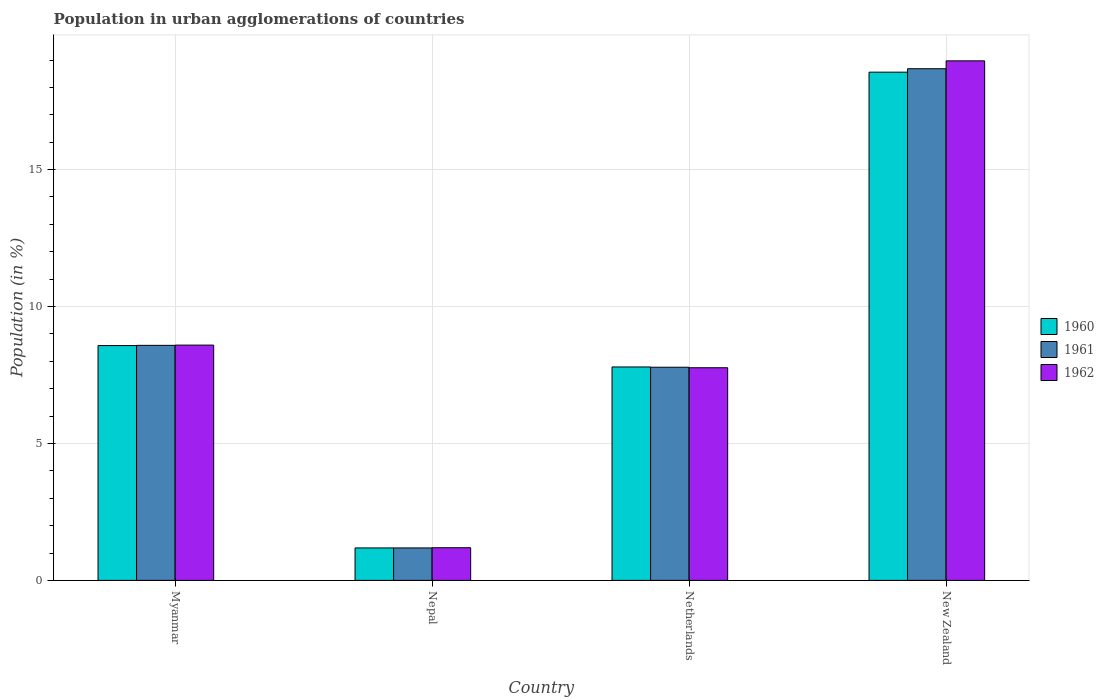How many groups of bars are there?
Provide a succinct answer. 4. Are the number of bars per tick equal to the number of legend labels?
Your answer should be very brief. Yes. Are the number of bars on each tick of the X-axis equal?
Ensure brevity in your answer.  Yes. How many bars are there on the 1st tick from the left?
Offer a very short reply. 3. What is the label of the 4th group of bars from the left?
Make the answer very short. New Zealand. What is the percentage of population in urban agglomerations in 1961 in Netherlands?
Give a very brief answer. 7.78. Across all countries, what is the maximum percentage of population in urban agglomerations in 1961?
Offer a terse response. 18.68. Across all countries, what is the minimum percentage of population in urban agglomerations in 1962?
Your answer should be very brief. 1.19. In which country was the percentage of population in urban agglomerations in 1960 maximum?
Keep it short and to the point. New Zealand. In which country was the percentage of population in urban agglomerations in 1960 minimum?
Offer a very short reply. Nepal. What is the total percentage of population in urban agglomerations in 1961 in the graph?
Ensure brevity in your answer.  36.23. What is the difference between the percentage of population in urban agglomerations in 1961 in Nepal and that in Netherlands?
Keep it short and to the point. -6.6. What is the difference between the percentage of population in urban agglomerations in 1960 in Nepal and the percentage of population in urban agglomerations in 1962 in Myanmar?
Make the answer very short. -7.41. What is the average percentage of population in urban agglomerations in 1962 per country?
Ensure brevity in your answer.  9.13. What is the difference between the percentage of population in urban agglomerations of/in 1962 and percentage of population in urban agglomerations of/in 1961 in Nepal?
Offer a terse response. 0.01. What is the ratio of the percentage of population in urban agglomerations in 1961 in Netherlands to that in New Zealand?
Offer a very short reply. 0.42. Is the difference between the percentage of population in urban agglomerations in 1962 in Myanmar and Netherlands greater than the difference between the percentage of population in urban agglomerations in 1961 in Myanmar and Netherlands?
Keep it short and to the point. Yes. What is the difference between the highest and the second highest percentage of population in urban agglomerations in 1960?
Ensure brevity in your answer.  -9.98. What is the difference between the highest and the lowest percentage of population in urban agglomerations in 1961?
Offer a very short reply. 17.5. Is the sum of the percentage of population in urban agglomerations in 1960 in Netherlands and New Zealand greater than the maximum percentage of population in urban agglomerations in 1962 across all countries?
Provide a succinct answer. Yes. Is it the case that in every country, the sum of the percentage of population in urban agglomerations in 1961 and percentage of population in urban agglomerations in 1962 is greater than the percentage of population in urban agglomerations in 1960?
Provide a short and direct response. Yes. Are all the bars in the graph horizontal?
Your answer should be compact. No. Are the values on the major ticks of Y-axis written in scientific E-notation?
Provide a short and direct response. No. Does the graph contain any zero values?
Provide a short and direct response. No. Where does the legend appear in the graph?
Offer a terse response. Center right. What is the title of the graph?
Provide a short and direct response. Population in urban agglomerations of countries. What is the label or title of the Y-axis?
Your answer should be very brief. Population (in %). What is the Population (in %) of 1960 in Myanmar?
Ensure brevity in your answer.  8.57. What is the Population (in %) of 1961 in Myanmar?
Provide a succinct answer. 8.58. What is the Population (in %) in 1962 in Myanmar?
Your response must be concise. 8.59. What is the Population (in %) of 1960 in Nepal?
Keep it short and to the point. 1.19. What is the Population (in %) of 1961 in Nepal?
Offer a very short reply. 1.19. What is the Population (in %) in 1962 in Nepal?
Your answer should be compact. 1.19. What is the Population (in %) of 1960 in Netherlands?
Your answer should be compact. 7.79. What is the Population (in %) in 1961 in Netherlands?
Ensure brevity in your answer.  7.78. What is the Population (in %) in 1962 in Netherlands?
Offer a terse response. 7.77. What is the Population (in %) in 1960 in New Zealand?
Provide a short and direct response. 18.56. What is the Population (in %) of 1961 in New Zealand?
Provide a short and direct response. 18.68. What is the Population (in %) in 1962 in New Zealand?
Keep it short and to the point. 18.97. Across all countries, what is the maximum Population (in %) of 1960?
Provide a succinct answer. 18.56. Across all countries, what is the maximum Population (in %) of 1961?
Keep it short and to the point. 18.68. Across all countries, what is the maximum Population (in %) of 1962?
Make the answer very short. 18.97. Across all countries, what is the minimum Population (in %) of 1960?
Your answer should be very brief. 1.19. Across all countries, what is the minimum Population (in %) of 1961?
Your answer should be very brief. 1.19. Across all countries, what is the minimum Population (in %) in 1962?
Your answer should be compact. 1.19. What is the total Population (in %) in 1960 in the graph?
Offer a terse response. 36.11. What is the total Population (in %) of 1961 in the graph?
Provide a succinct answer. 36.23. What is the total Population (in %) in 1962 in the graph?
Your answer should be compact. 36.52. What is the difference between the Population (in %) of 1960 in Myanmar and that in Nepal?
Offer a terse response. 7.39. What is the difference between the Population (in %) in 1961 in Myanmar and that in Nepal?
Offer a very short reply. 7.4. What is the difference between the Population (in %) of 1962 in Myanmar and that in Nepal?
Make the answer very short. 7.4. What is the difference between the Population (in %) in 1960 in Myanmar and that in Netherlands?
Your answer should be compact. 0.78. What is the difference between the Population (in %) of 1961 in Myanmar and that in Netherlands?
Offer a very short reply. 0.8. What is the difference between the Population (in %) of 1962 in Myanmar and that in Netherlands?
Offer a very short reply. 0.83. What is the difference between the Population (in %) in 1960 in Myanmar and that in New Zealand?
Provide a short and direct response. -9.98. What is the difference between the Population (in %) in 1961 in Myanmar and that in New Zealand?
Your answer should be compact. -10.1. What is the difference between the Population (in %) of 1962 in Myanmar and that in New Zealand?
Provide a short and direct response. -10.38. What is the difference between the Population (in %) of 1960 in Nepal and that in Netherlands?
Offer a terse response. -6.61. What is the difference between the Population (in %) of 1961 in Nepal and that in Netherlands?
Provide a succinct answer. -6.6. What is the difference between the Population (in %) in 1962 in Nepal and that in Netherlands?
Your answer should be compact. -6.57. What is the difference between the Population (in %) of 1960 in Nepal and that in New Zealand?
Ensure brevity in your answer.  -17.37. What is the difference between the Population (in %) in 1961 in Nepal and that in New Zealand?
Your answer should be compact. -17.5. What is the difference between the Population (in %) of 1962 in Nepal and that in New Zealand?
Your answer should be very brief. -17.78. What is the difference between the Population (in %) in 1960 in Netherlands and that in New Zealand?
Offer a terse response. -10.76. What is the difference between the Population (in %) of 1961 in Netherlands and that in New Zealand?
Keep it short and to the point. -10.9. What is the difference between the Population (in %) of 1962 in Netherlands and that in New Zealand?
Give a very brief answer. -11.21. What is the difference between the Population (in %) of 1960 in Myanmar and the Population (in %) of 1961 in Nepal?
Offer a very short reply. 7.39. What is the difference between the Population (in %) of 1960 in Myanmar and the Population (in %) of 1962 in Nepal?
Provide a short and direct response. 7.38. What is the difference between the Population (in %) of 1961 in Myanmar and the Population (in %) of 1962 in Nepal?
Offer a terse response. 7.39. What is the difference between the Population (in %) of 1960 in Myanmar and the Population (in %) of 1961 in Netherlands?
Give a very brief answer. 0.79. What is the difference between the Population (in %) of 1960 in Myanmar and the Population (in %) of 1962 in Netherlands?
Make the answer very short. 0.81. What is the difference between the Population (in %) of 1961 in Myanmar and the Population (in %) of 1962 in Netherlands?
Provide a succinct answer. 0.82. What is the difference between the Population (in %) in 1960 in Myanmar and the Population (in %) in 1961 in New Zealand?
Ensure brevity in your answer.  -10.11. What is the difference between the Population (in %) in 1960 in Myanmar and the Population (in %) in 1962 in New Zealand?
Your answer should be compact. -10.4. What is the difference between the Population (in %) of 1961 in Myanmar and the Population (in %) of 1962 in New Zealand?
Offer a very short reply. -10.39. What is the difference between the Population (in %) in 1960 in Nepal and the Population (in %) in 1961 in Netherlands?
Keep it short and to the point. -6.6. What is the difference between the Population (in %) of 1960 in Nepal and the Population (in %) of 1962 in Netherlands?
Give a very brief answer. -6.58. What is the difference between the Population (in %) in 1961 in Nepal and the Population (in %) in 1962 in Netherlands?
Your answer should be compact. -6.58. What is the difference between the Population (in %) of 1960 in Nepal and the Population (in %) of 1961 in New Zealand?
Ensure brevity in your answer.  -17.5. What is the difference between the Population (in %) of 1960 in Nepal and the Population (in %) of 1962 in New Zealand?
Your response must be concise. -17.79. What is the difference between the Population (in %) of 1961 in Nepal and the Population (in %) of 1962 in New Zealand?
Provide a succinct answer. -17.79. What is the difference between the Population (in %) in 1960 in Netherlands and the Population (in %) in 1961 in New Zealand?
Offer a very short reply. -10.89. What is the difference between the Population (in %) in 1960 in Netherlands and the Population (in %) in 1962 in New Zealand?
Keep it short and to the point. -11.18. What is the difference between the Population (in %) in 1961 in Netherlands and the Population (in %) in 1962 in New Zealand?
Keep it short and to the point. -11.19. What is the average Population (in %) in 1960 per country?
Make the answer very short. 9.03. What is the average Population (in %) of 1961 per country?
Your answer should be very brief. 9.06. What is the average Population (in %) in 1962 per country?
Make the answer very short. 9.13. What is the difference between the Population (in %) of 1960 and Population (in %) of 1961 in Myanmar?
Your response must be concise. -0.01. What is the difference between the Population (in %) of 1960 and Population (in %) of 1962 in Myanmar?
Provide a short and direct response. -0.02. What is the difference between the Population (in %) of 1961 and Population (in %) of 1962 in Myanmar?
Ensure brevity in your answer.  -0.01. What is the difference between the Population (in %) of 1960 and Population (in %) of 1961 in Nepal?
Offer a very short reply. -0. What is the difference between the Population (in %) of 1960 and Population (in %) of 1962 in Nepal?
Your answer should be very brief. -0.01. What is the difference between the Population (in %) of 1961 and Population (in %) of 1962 in Nepal?
Your answer should be compact. -0.01. What is the difference between the Population (in %) of 1960 and Population (in %) of 1961 in Netherlands?
Offer a terse response. 0.01. What is the difference between the Population (in %) in 1960 and Population (in %) in 1962 in Netherlands?
Keep it short and to the point. 0.03. What is the difference between the Population (in %) in 1961 and Population (in %) in 1962 in Netherlands?
Provide a short and direct response. 0.02. What is the difference between the Population (in %) of 1960 and Population (in %) of 1961 in New Zealand?
Provide a succinct answer. -0.13. What is the difference between the Population (in %) of 1960 and Population (in %) of 1962 in New Zealand?
Your answer should be compact. -0.41. What is the difference between the Population (in %) of 1961 and Population (in %) of 1962 in New Zealand?
Offer a terse response. -0.29. What is the ratio of the Population (in %) in 1960 in Myanmar to that in Nepal?
Offer a very short reply. 7.24. What is the ratio of the Population (in %) of 1961 in Myanmar to that in Nepal?
Your response must be concise. 7.24. What is the ratio of the Population (in %) of 1962 in Myanmar to that in Nepal?
Offer a terse response. 7.2. What is the ratio of the Population (in %) in 1960 in Myanmar to that in Netherlands?
Your answer should be compact. 1.1. What is the ratio of the Population (in %) of 1961 in Myanmar to that in Netherlands?
Give a very brief answer. 1.1. What is the ratio of the Population (in %) in 1962 in Myanmar to that in Netherlands?
Make the answer very short. 1.11. What is the ratio of the Population (in %) of 1960 in Myanmar to that in New Zealand?
Make the answer very short. 0.46. What is the ratio of the Population (in %) of 1961 in Myanmar to that in New Zealand?
Give a very brief answer. 0.46. What is the ratio of the Population (in %) in 1962 in Myanmar to that in New Zealand?
Make the answer very short. 0.45. What is the ratio of the Population (in %) of 1960 in Nepal to that in Netherlands?
Make the answer very short. 0.15. What is the ratio of the Population (in %) in 1961 in Nepal to that in Netherlands?
Make the answer very short. 0.15. What is the ratio of the Population (in %) of 1962 in Nepal to that in Netherlands?
Make the answer very short. 0.15. What is the ratio of the Population (in %) in 1960 in Nepal to that in New Zealand?
Your answer should be very brief. 0.06. What is the ratio of the Population (in %) of 1961 in Nepal to that in New Zealand?
Provide a short and direct response. 0.06. What is the ratio of the Population (in %) of 1962 in Nepal to that in New Zealand?
Your answer should be compact. 0.06. What is the ratio of the Population (in %) in 1960 in Netherlands to that in New Zealand?
Your answer should be very brief. 0.42. What is the ratio of the Population (in %) in 1961 in Netherlands to that in New Zealand?
Keep it short and to the point. 0.42. What is the ratio of the Population (in %) of 1962 in Netherlands to that in New Zealand?
Ensure brevity in your answer.  0.41. What is the difference between the highest and the second highest Population (in %) in 1960?
Offer a terse response. 9.98. What is the difference between the highest and the second highest Population (in %) in 1961?
Your answer should be compact. 10.1. What is the difference between the highest and the second highest Population (in %) in 1962?
Your response must be concise. 10.38. What is the difference between the highest and the lowest Population (in %) of 1960?
Offer a terse response. 17.37. What is the difference between the highest and the lowest Population (in %) of 1961?
Offer a very short reply. 17.5. What is the difference between the highest and the lowest Population (in %) of 1962?
Your answer should be very brief. 17.78. 